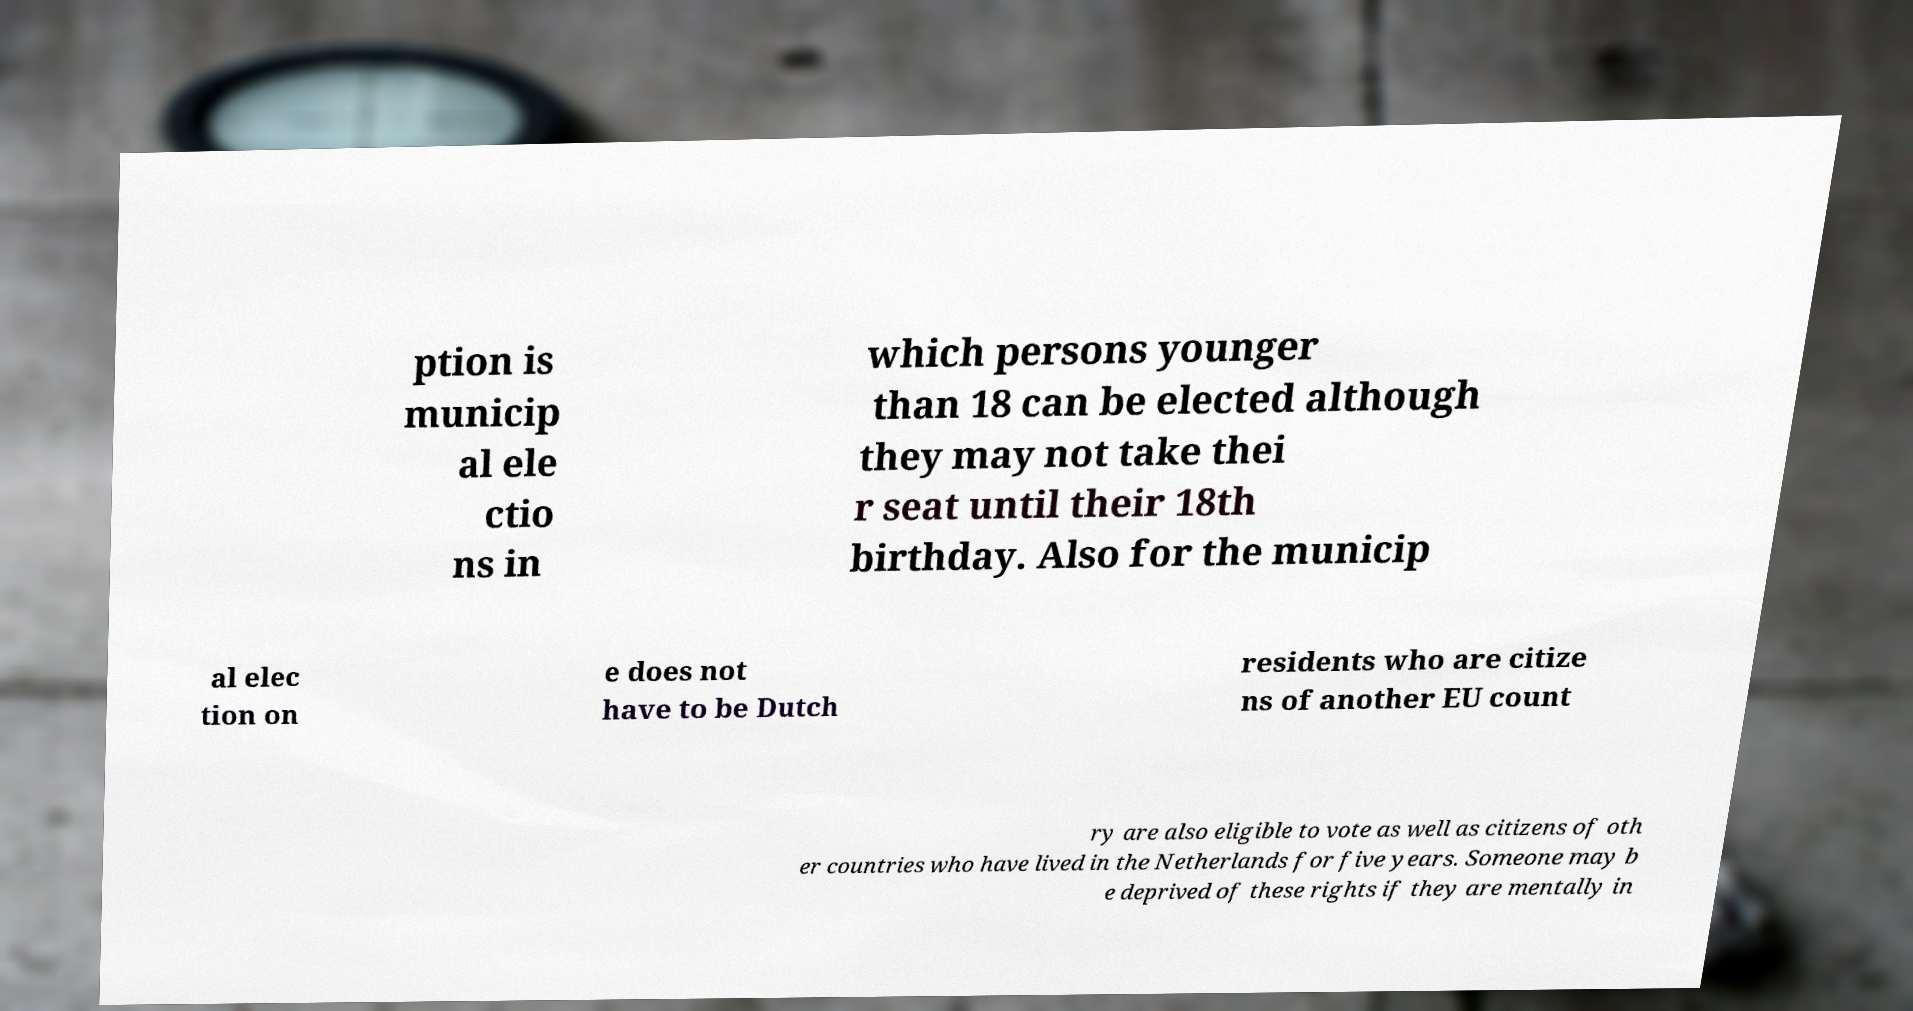Can you read and provide the text displayed in the image?This photo seems to have some interesting text. Can you extract and type it out for me? ption is municip al ele ctio ns in which persons younger than 18 can be elected although they may not take thei r seat until their 18th birthday. Also for the municip al elec tion on e does not have to be Dutch residents who are citize ns of another EU count ry are also eligible to vote as well as citizens of oth er countries who have lived in the Netherlands for five years. Someone may b e deprived of these rights if they are mentally in 